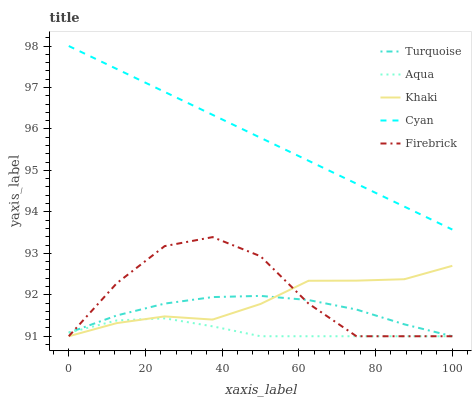Does Aqua have the minimum area under the curve?
Answer yes or no. Yes. Does Cyan have the maximum area under the curve?
Answer yes or no. Yes. Does Turquoise have the minimum area under the curve?
Answer yes or no. No. Does Turquoise have the maximum area under the curve?
Answer yes or no. No. Is Cyan the smoothest?
Answer yes or no. Yes. Is Firebrick the roughest?
Answer yes or no. Yes. Is Turquoise the smoothest?
Answer yes or no. No. Is Turquoise the roughest?
Answer yes or no. No. Does Cyan have the highest value?
Answer yes or no. Yes. Does Turquoise have the highest value?
Answer yes or no. No. Is Firebrick less than Cyan?
Answer yes or no. Yes. Is Cyan greater than Turquoise?
Answer yes or no. Yes. Does Aqua intersect Khaki?
Answer yes or no. Yes. Is Aqua less than Khaki?
Answer yes or no. No. Is Aqua greater than Khaki?
Answer yes or no. No. Does Firebrick intersect Cyan?
Answer yes or no. No. 